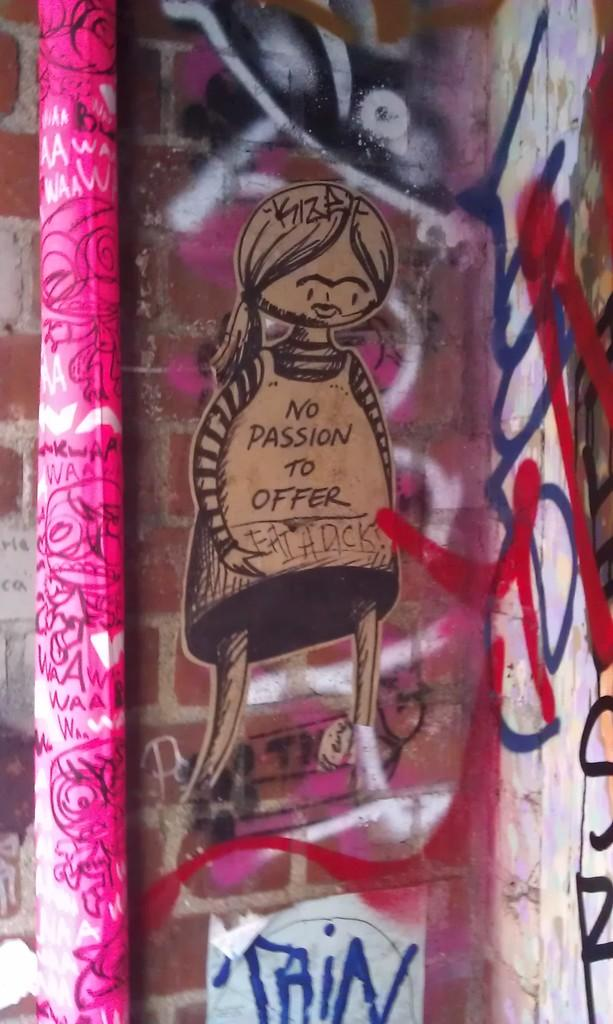What is the main object in the picture? There is a pole in the picture. What else can be seen in the picture besides the pole? There are paintings and designs visible in the picture. What type of wall is partially visible in the picture? The wall has bricks on it. Can you tell me how many flowers are on the grandmother's hat in the picture? There is no grandmother or hat with flowers present in the image. 